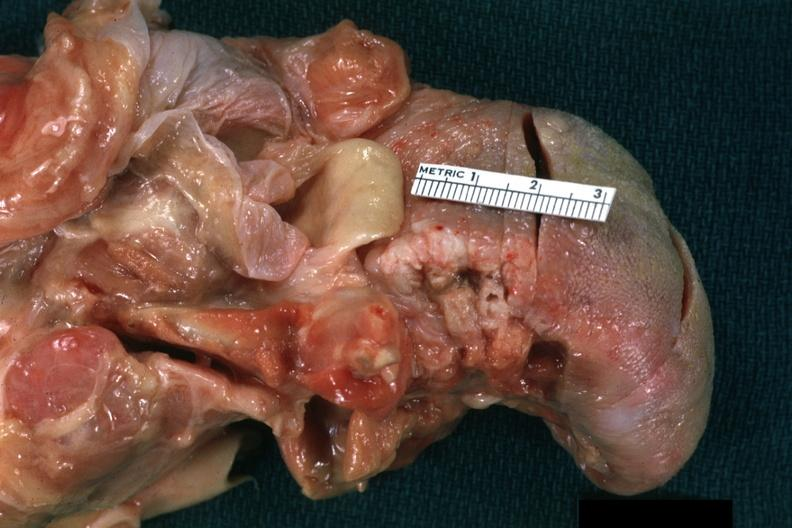s squamous cell carcinoma present?
Answer the question using a single word or phrase. Yes 